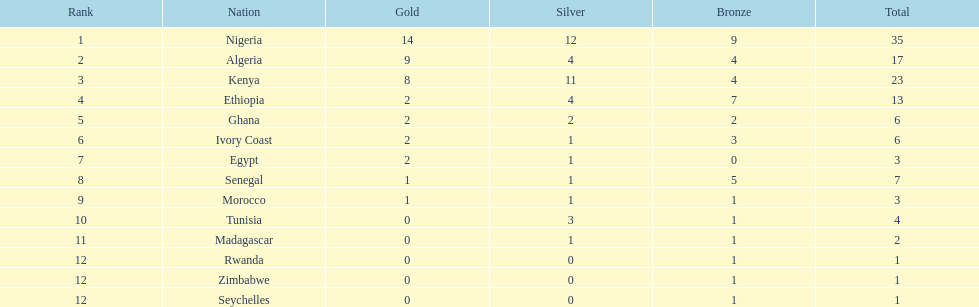Which country secured the lowest count of bronze medals? Egypt. 